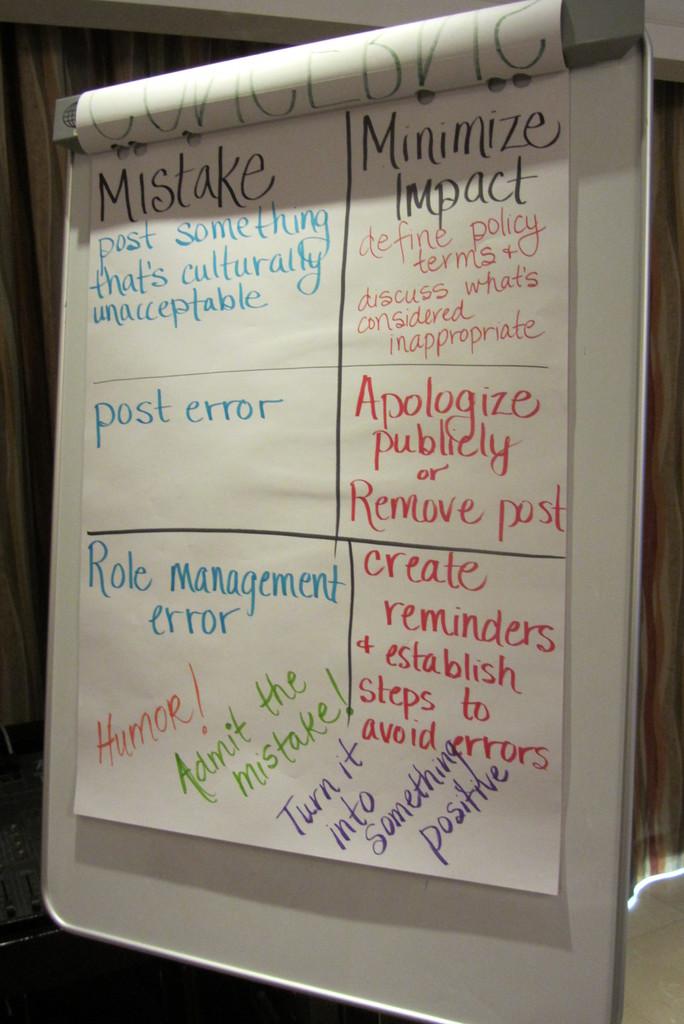What should you admit?
Your answer should be very brief. The mistake. What is the only word written in orange?
Make the answer very short. Humor. 